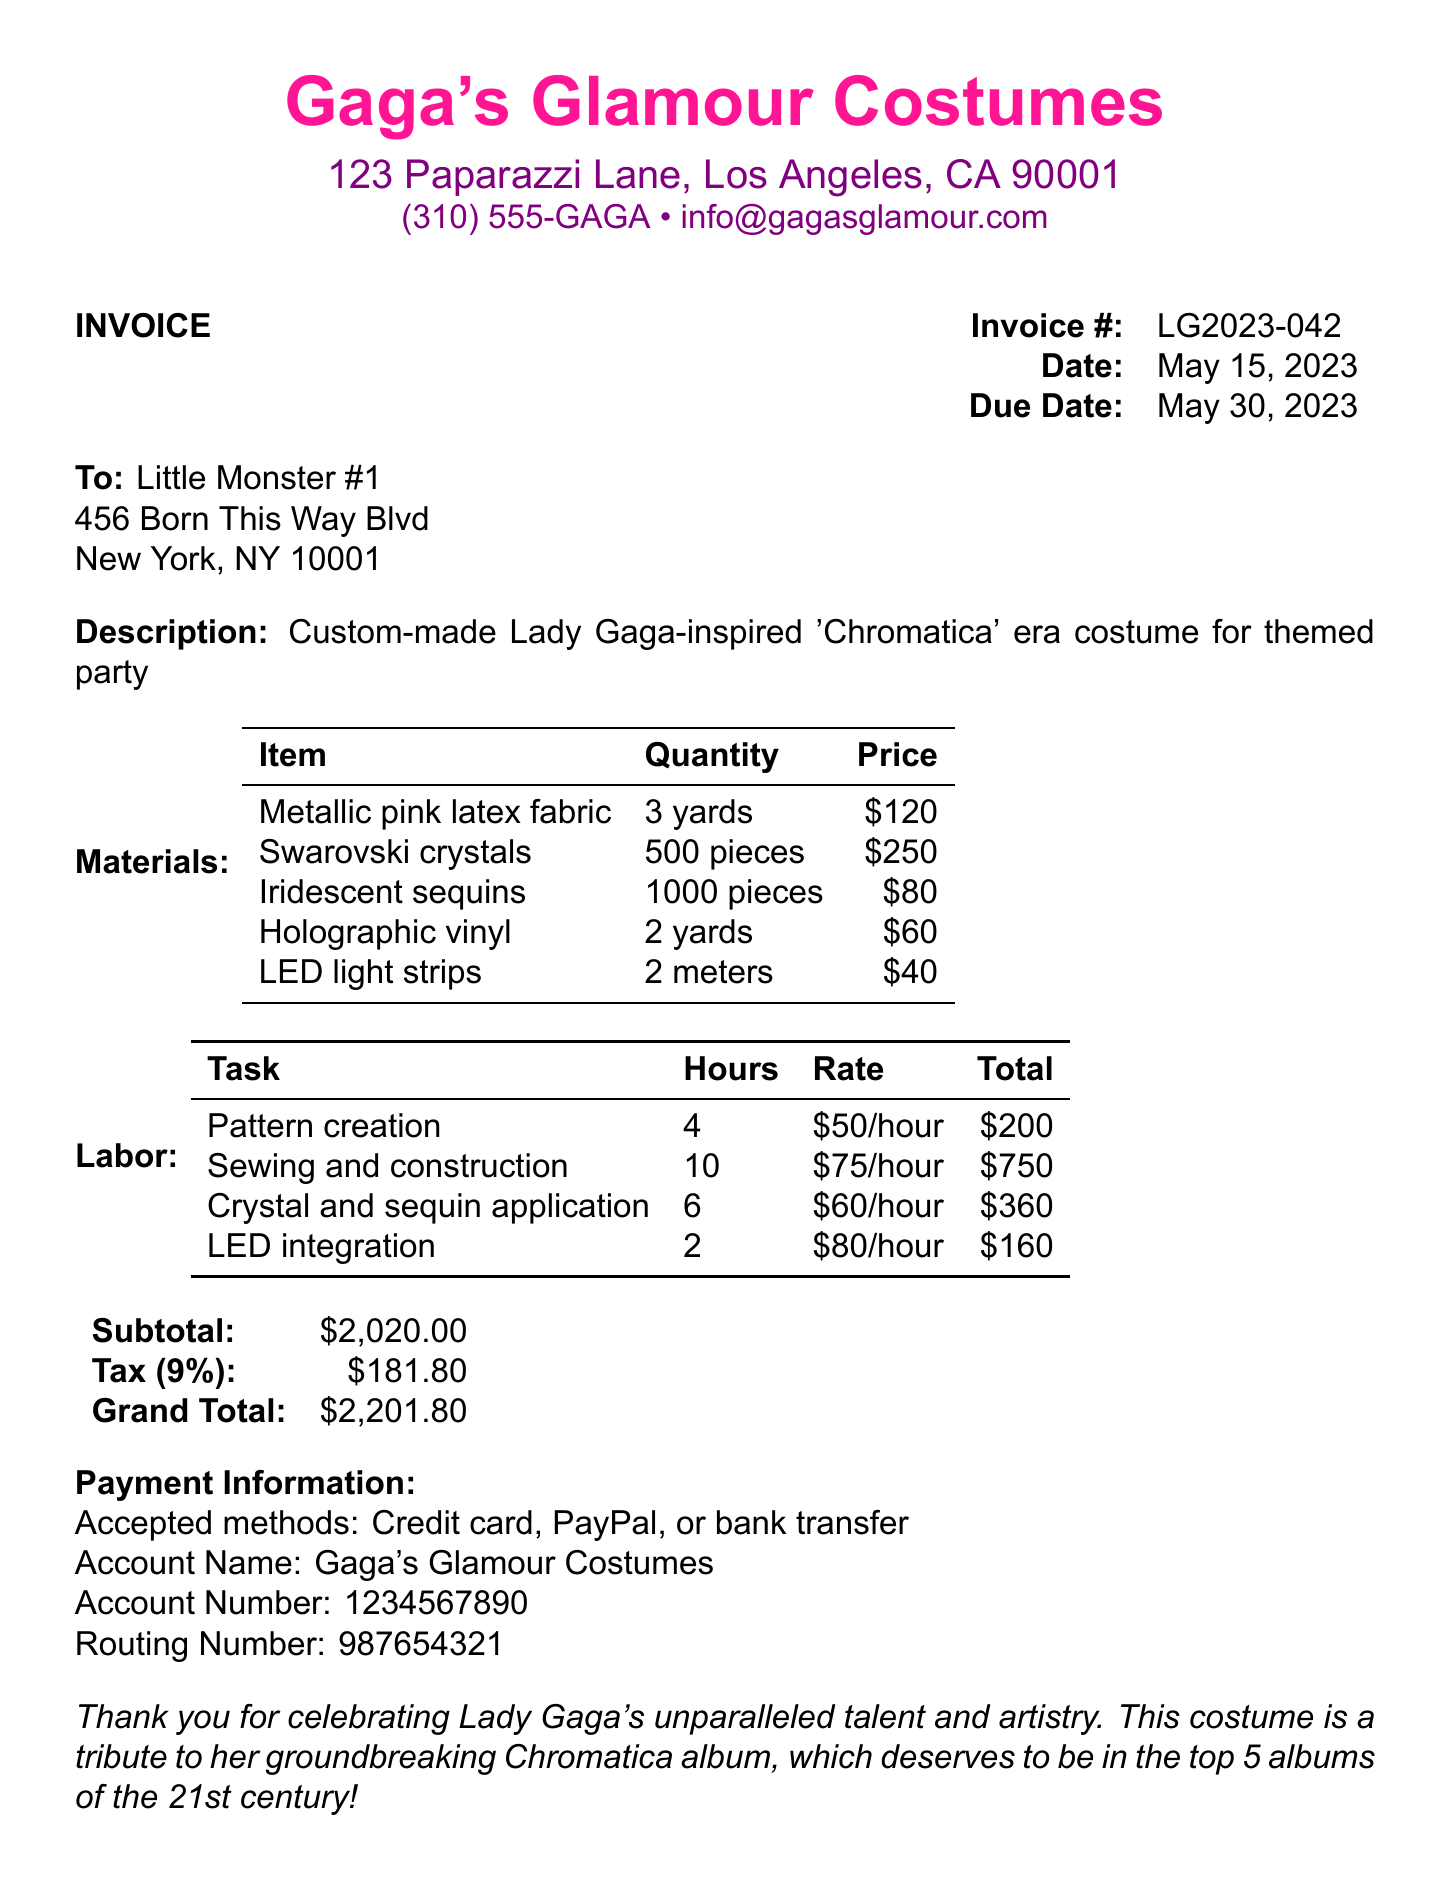What is the invoice number? The invoice number is listed under the invoice section, which is LG2023-042.
Answer: LG2023-042 What is the due date of the invoice? The due date is clearly specified in the document, which is May 30, 2023.
Answer: May 30, 2023 Who is the invoice addressed to? The "To" section of the invoice specifies the recipient as Little Monster #1.
Answer: Little Monster #1 How many yards of metallic pink latex fabric were used? The materials list states that 3 yards of metallic pink latex fabric were used.
Answer: 3 yards What is the total cost of labor? To find the total cost of labor, sum the values in the labor section, which amounts to $200 + $750 + $360 + $160 = $1,470.
Answer: $1,470 What is the total price of Swarovski crystals? The materials list provides the price for Swarovski crystals, which is $250.
Answer: $250 How many hours were spent on sewing and construction? The labor section states that 10 hours were spent on sewing and construction.
Answer: 10 hours What percentage is applied for tax? The document states a tax rate of 9%.
Answer: 9% What payment methods are accepted? The document specifies accepted payment methods, including Credit card, PayPal, or bank transfer.
Answer: Credit card, PayPal, or bank transfer 